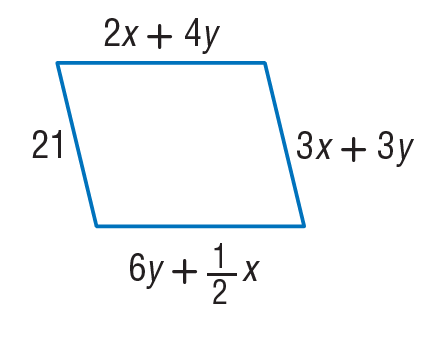Answer the mathemtical geometry problem and directly provide the correct option letter.
Question: Find y so that the quadrilateral is a parallelogram.
Choices: A: 3 B: 6 C: 9 D: 12 A 